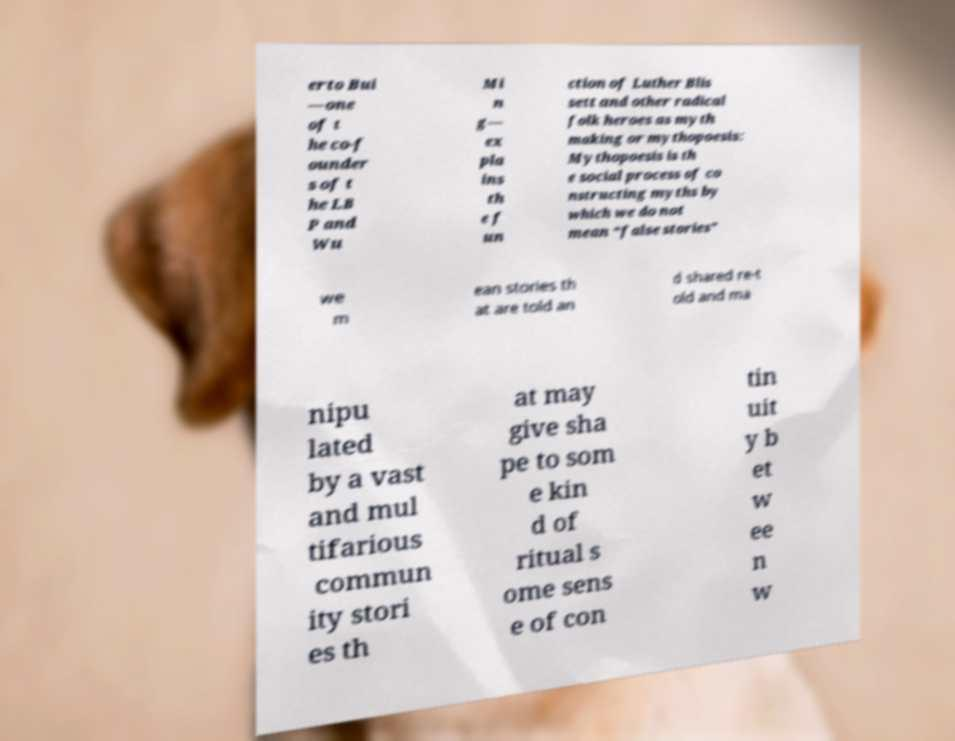Please read and relay the text visible in this image. What does it say? erto Bui —one of t he co-f ounder s of t he LB P and Wu Mi n g— ex pla ins th e f un ction of Luther Blis sett and other radical folk heroes as myth making or mythopoesis: Mythopoesis is th e social process of co nstructing myths by which we do not mean “false stories” we m ean stories th at are told an d shared re-t old and ma nipu lated by a vast and mul tifarious commun ity stori es th at may give sha pe to som e kin d of ritual s ome sens e of con tin uit y b et w ee n w 